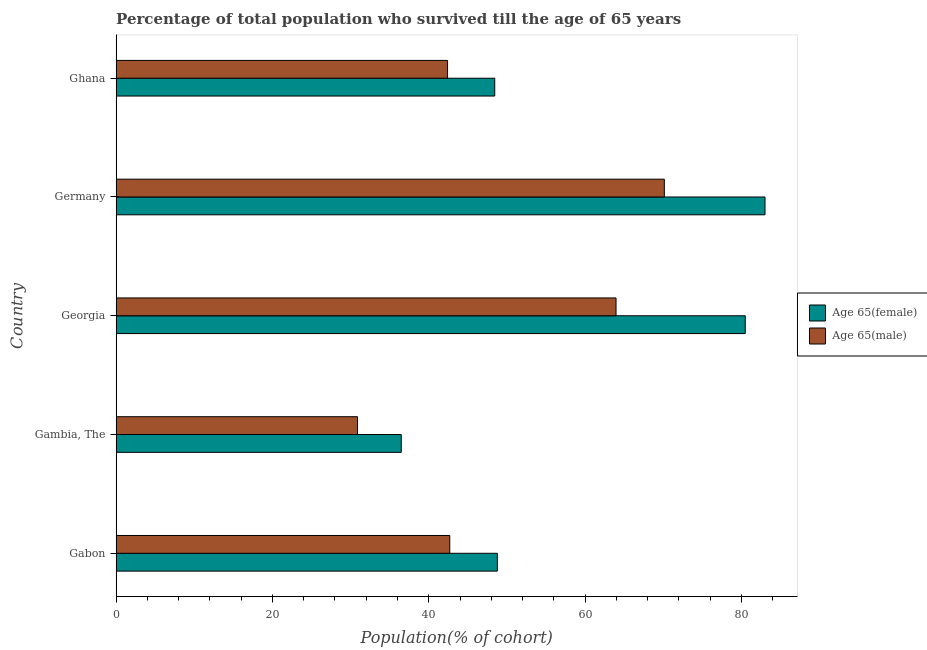Are the number of bars on each tick of the Y-axis equal?
Keep it short and to the point. Yes. How many bars are there on the 4th tick from the top?
Provide a succinct answer. 2. What is the label of the 1st group of bars from the top?
Keep it short and to the point. Ghana. In how many cases, is the number of bars for a given country not equal to the number of legend labels?
Your answer should be very brief. 0. What is the percentage of male population who survived till age of 65 in Gambia, The?
Your response must be concise. 30.88. Across all countries, what is the maximum percentage of female population who survived till age of 65?
Your response must be concise. 83.02. Across all countries, what is the minimum percentage of male population who survived till age of 65?
Offer a very short reply. 30.88. In which country was the percentage of female population who survived till age of 65 minimum?
Make the answer very short. Gambia, The. What is the total percentage of male population who survived till age of 65 in the graph?
Provide a short and direct response. 250.07. What is the difference between the percentage of female population who survived till age of 65 in Georgia and that in Ghana?
Your answer should be very brief. 32.05. What is the difference between the percentage of male population who survived till age of 65 in Ghana and the percentage of female population who survived till age of 65 in Georgia?
Keep it short and to the point. -38.09. What is the average percentage of female population who survived till age of 65 per country?
Give a very brief answer. 59.44. What is the difference between the percentage of male population who survived till age of 65 and percentage of female population who survived till age of 65 in Gabon?
Give a very brief answer. -6.08. In how many countries, is the percentage of female population who survived till age of 65 greater than 8 %?
Provide a succinct answer. 5. What is the ratio of the percentage of female population who survived till age of 65 in Gambia, The to that in Germany?
Provide a short and direct response. 0.44. Is the percentage of male population who survived till age of 65 in Gambia, The less than that in Germany?
Keep it short and to the point. Yes. What is the difference between the highest and the second highest percentage of female population who survived till age of 65?
Your answer should be very brief. 2.53. What is the difference between the highest and the lowest percentage of male population who survived till age of 65?
Make the answer very short. 39.26. In how many countries, is the percentage of male population who survived till age of 65 greater than the average percentage of male population who survived till age of 65 taken over all countries?
Keep it short and to the point. 2. Is the sum of the percentage of male population who survived till age of 65 in Georgia and Germany greater than the maximum percentage of female population who survived till age of 65 across all countries?
Your answer should be compact. Yes. What does the 1st bar from the top in Gabon represents?
Give a very brief answer. Age 65(male). What does the 1st bar from the bottom in Georgia represents?
Provide a short and direct response. Age 65(female). How many bars are there?
Ensure brevity in your answer.  10. Does the graph contain any zero values?
Your response must be concise. No. Where does the legend appear in the graph?
Your answer should be compact. Center right. How are the legend labels stacked?
Give a very brief answer. Vertical. What is the title of the graph?
Offer a very short reply. Percentage of total population who survived till the age of 65 years. Does "Working only" appear as one of the legend labels in the graph?
Keep it short and to the point. No. What is the label or title of the X-axis?
Ensure brevity in your answer.  Population(% of cohort). What is the Population(% of cohort) of Age 65(female) in Gabon?
Keep it short and to the point. 48.77. What is the Population(% of cohort) in Age 65(male) in Gabon?
Offer a terse response. 42.69. What is the Population(% of cohort) of Age 65(female) in Gambia, The?
Keep it short and to the point. 36.48. What is the Population(% of cohort) in Age 65(male) in Gambia, The?
Offer a very short reply. 30.88. What is the Population(% of cohort) of Age 65(female) in Georgia?
Provide a short and direct response. 80.49. What is the Population(% of cohort) in Age 65(male) in Georgia?
Your answer should be compact. 63.96. What is the Population(% of cohort) in Age 65(female) in Germany?
Offer a very short reply. 83.02. What is the Population(% of cohort) in Age 65(male) in Germany?
Your response must be concise. 70.14. What is the Population(% of cohort) in Age 65(female) in Ghana?
Give a very brief answer. 48.44. What is the Population(% of cohort) in Age 65(male) in Ghana?
Your answer should be compact. 42.4. Across all countries, what is the maximum Population(% of cohort) of Age 65(female)?
Give a very brief answer. 83.02. Across all countries, what is the maximum Population(% of cohort) of Age 65(male)?
Offer a very short reply. 70.14. Across all countries, what is the minimum Population(% of cohort) of Age 65(female)?
Give a very brief answer. 36.48. Across all countries, what is the minimum Population(% of cohort) in Age 65(male)?
Keep it short and to the point. 30.88. What is the total Population(% of cohort) in Age 65(female) in the graph?
Give a very brief answer. 297.21. What is the total Population(% of cohort) of Age 65(male) in the graph?
Your answer should be very brief. 250.07. What is the difference between the Population(% of cohort) in Age 65(female) in Gabon and that in Gambia, The?
Offer a terse response. 12.29. What is the difference between the Population(% of cohort) in Age 65(male) in Gabon and that in Gambia, The?
Offer a very short reply. 11.81. What is the difference between the Population(% of cohort) of Age 65(female) in Gabon and that in Georgia?
Offer a very short reply. -31.72. What is the difference between the Population(% of cohort) in Age 65(male) in Gabon and that in Georgia?
Offer a terse response. -21.27. What is the difference between the Population(% of cohort) in Age 65(female) in Gabon and that in Germany?
Your response must be concise. -34.25. What is the difference between the Population(% of cohort) in Age 65(male) in Gabon and that in Germany?
Your response must be concise. -27.45. What is the difference between the Population(% of cohort) of Age 65(female) in Gabon and that in Ghana?
Your answer should be compact. 0.33. What is the difference between the Population(% of cohort) in Age 65(male) in Gabon and that in Ghana?
Your answer should be compact. 0.29. What is the difference between the Population(% of cohort) of Age 65(female) in Gambia, The and that in Georgia?
Provide a short and direct response. -44.01. What is the difference between the Population(% of cohort) in Age 65(male) in Gambia, The and that in Georgia?
Offer a terse response. -33.08. What is the difference between the Population(% of cohort) of Age 65(female) in Gambia, The and that in Germany?
Offer a terse response. -46.54. What is the difference between the Population(% of cohort) of Age 65(male) in Gambia, The and that in Germany?
Provide a succinct answer. -39.26. What is the difference between the Population(% of cohort) in Age 65(female) in Gambia, The and that in Ghana?
Ensure brevity in your answer.  -11.96. What is the difference between the Population(% of cohort) in Age 65(male) in Gambia, The and that in Ghana?
Keep it short and to the point. -11.52. What is the difference between the Population(% of cohort) of Age 65(female) in Georgia and that in Germany?
Offer a very short reply. -2.53. What is the difference between the Population(% of cohort) in Age 65(male) in Georgia and that in Germany?
Your answer should be very brief. -6.18. What is the difference between the Population(% of cohort) in Age 65(female) in Georgia and that in Ghana?
Offer a terse response. 32.05. What is the difference between the Population(% of cohort) of Age 65(male) in Georgia and that in Ghana?
Your answer should be compact. 21.56. What is the difference between the Population(% of cohort) in Age 65(female) in Germany and that in Ghana?
Give a very brief answer. 34.58. What is the difference between the Population(% of cohort) in Age 65(male) in Germany and that in Ghana?
Keep it short and to the point. 27.74. What is the difference between the Population(% of cohort) in Age 65(female) in Gabon and the Population(% of cohort) in Age 65(male) in Gambia, The?
Offer a terse response. 17.89. What is the difference between the Population(% of cohort) in Age 65(female) in Gabon and the Population(% of cohort) in Age 65(male) in Georgia?
Give a very brief answer. -15.19. What is the difference between the Population(% of cohort) in Age 65(female) in Gabon and the Population(% of cohort) in Age 65(male) in Germany?
Offer a very short reply. -21.37. What is the difference between the Population(% of cohort) in Age 65(female) in Gabon and the Population(% of cohort) in Age 65(male) in Ghana?
Ensure brevity in your answer.  6.37. What is the difference between the Population(% of cohort) in Age 65(female) in Gambia, The and the Population(% of cohort) in Age 65(male) in Georgia?
Make the answer very short. -27.48. What is the difference between the Population(% of cohort) in Age 65(female) in Gambia, The and the Population(% of cohort) in Age 65(male) in Germany?
Keep it short and to the point. -33.66. What is the difference between the Population(% of cohort) in Age 65(female) in Gambia, The and the Population(% of cohort) in Age 65(male) in Ghana?
Offer a very short reply. -5.92. What is the difference between the Population(% of cohort) of Age 65(female) in Georgia and the Population(% of cohort) of Age 65(male) in Germany?
Ensure brevity in your answer.  10.35. What is the difference between the Population(% of cohort) in Age 65(female) in Georgia and the Population(% of cohort) in Age 65(male) in Ghana?
Your answer should be compact. 38.09. What is the difference between the Population(% of cohort) in Age 65(female) in Germany and the Population(% of cohort) in Age 65(male) in Ghana?
Your answer should be very brief. 40.62. What is the average Population(% of cohort) in Age 65(female) per country?
Offer a terse response. 59.44. What is the average Population(% of cohort) of Age 65(male) per country?
Keep it short and to the point. 50.01. What is the difference between the Population(% of cohort) in Age 65(female) and Population(% of cohort) in Age 65(male) in Gabon?
Your response must be concise. 6.08. What is the difference between the Population(% of cohort) in Age 65(female) and Population(% of cohort) in Age 65(male) in Gambia, The?
Give a very brief answer. 5.6. What is the difference between the Population(% of cohort) of Age 65(female) and Population(% of cohort) of Age 65(male) in Georgia?
Provide a succinct answer. 16.53. What is the difference between the Population(% of cohort) in Age 65(female) and Population(% of cohort) in Age 65(male) in Germany?
Ensure brevity in your answer.  12.88. What is the difference between the Population(% of cohort) in Age 65(female) and Population(% of cohort) in Age 65(male) in Ghana?
Your response must be concise. 6.04. What is the ratio of the Population(% of cohort) in Age 65(female) in Gabon to that in Gambia, The?
Your answer should be compact. 1.34. What is the ratio of the Population(% of cohort) in Age 65(male) in Gabon to that in Gambia, The?
Ensure brevity in your answer.  1.38. What is the ratio of the Population(% of cohort) of Age 65(female) in Gabon to that in Georgia?
Provide a succinct answer. 0.61. What is the ratio of the Population(% of cohort) in Age 65(male) in Gabon to that in Georgia?
Ensure brevity in your answer.  0.67. What is the ratio of the Population(% of cohort) in Age 65(female) in Gabon to that in Germany?
Your answer should be very brief. 0.59. What is the ratio of the Population(% of cohort) in Age 65(male) in Gabon to that in Germany?
Keep it short and to the point. 0.61. What is the ratio of the Population(% of cohort) in Age 65(male) in Gabon to that in Ghana?
Your answer should be compact. 1.01. What is the ratio of the Population(% of cohort) in Age 65(female) in Gambia, The to that in Georgia?
Give a very brief answer. 0.45. What is the ratio of the Population(% of cohort) in Age 65(male) in Gambia, The to that in Georgia?
Provide a succinct answer. 0.48. What is the ratio of the Population(% of cohort) of Age 65(female) in Gambia, The to that in Germany?
Your response must be concise. 0.44. What is the ratio of the Population(% of cohort) of Age 65(male) in Gambia, The to that in Germany?
Make the answer very short. 0.44. What is the ratio of the Population(% of cohort) in Age 65(female) in Gambia, The to that in Ghana?
Your response must be concise. 0.75. What is the ratio of the Population(% of cohort) in Age 65(male) in Gambia, The to that in Ghana?
Give a very brief answer. 0.73. What is the ratio of the Population(% of cohort) of Age 65(female) in Georgia to that in Germany?
Give a very brief answer. 0.97. What is the ratio of the Population(% of cohort) in Age 65(male) in Georgia to that in Germany?
Provide a succinct answer. 0.91. What is the ratio of the Population(% of cohort) in Age 65(female) in Georgia to that in Ghana?
Offer a very short reply. 1.66. What is the ratio of the Population(% of cohort) in Age 65(male) in Georgia to that in Ghana?
Provide a succinct answer. 1.51. What is the ratio of the Population(% of cohort) in Age 65(female) in Germany to that in Ghana?
Your answer should be very brief. 1.71. What is the ratio of the Population(% of cohort) in Age 65(male) in Germany to that in Ghana?
Provide a short and direct response. 1.65. What is the difference between the highest and the second highest Population(% of cohort) in Age 65(female)?
Ensure brevity in your answer.  2.53. What is the difference between the highest and the second highest Population(% of cohort) in Age 65(male)?
Your answer should be very brief. 6.18. What is the difference between the highest and the lowest Population(% of cohort) of Age 65(female)?
Offer a terse response. 46.54. What is the difference between the highest and the lowest Population(% of cohort) of Age 65(male)?
Your response must be concise. 39.26. 